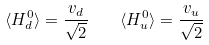Convert formula to latex. <formula><loc_0><loc_0><loc_500><loc_500>\langle H _ { d } ^ { 0 } \rangle = \frac { v _ { d } } { \sqrt { 2 } } \quad \langle H _ { u } ^ { 0 } \rangle = \frac { v _ { u } } { \sqrt { 2 } }</formula> 